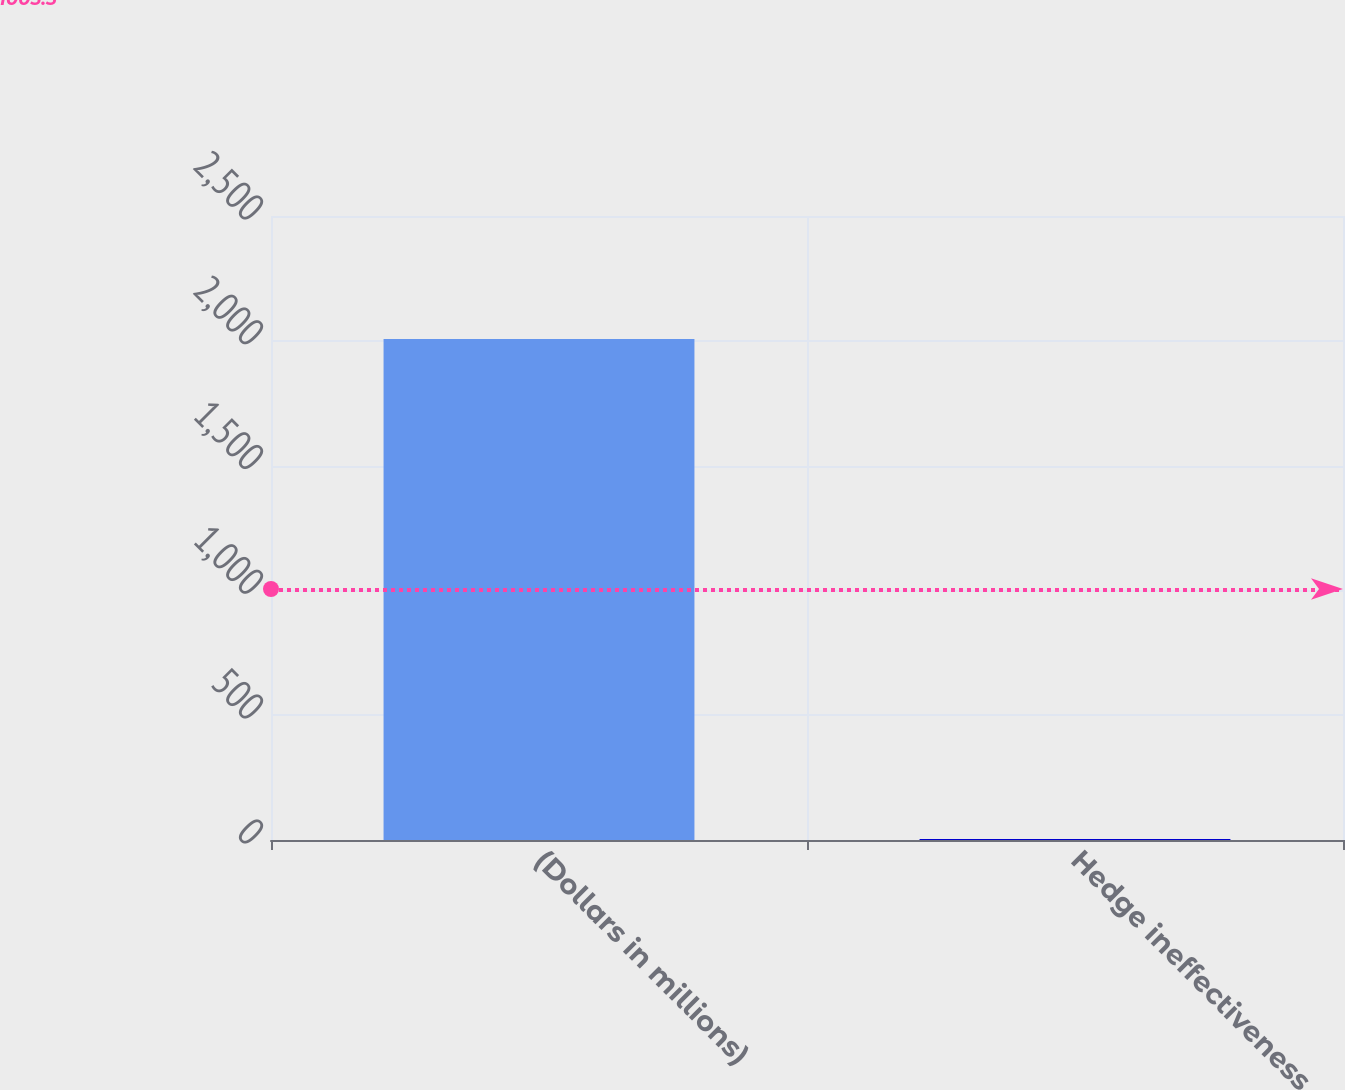<chart> <loc_0><loc_0><loc_500><loc_500><bar_chart><fcel>(Dollars in millions)<fcel>Hedge ineffectiveness<nl><fcel>2007<fcel>4<nl></chart> 